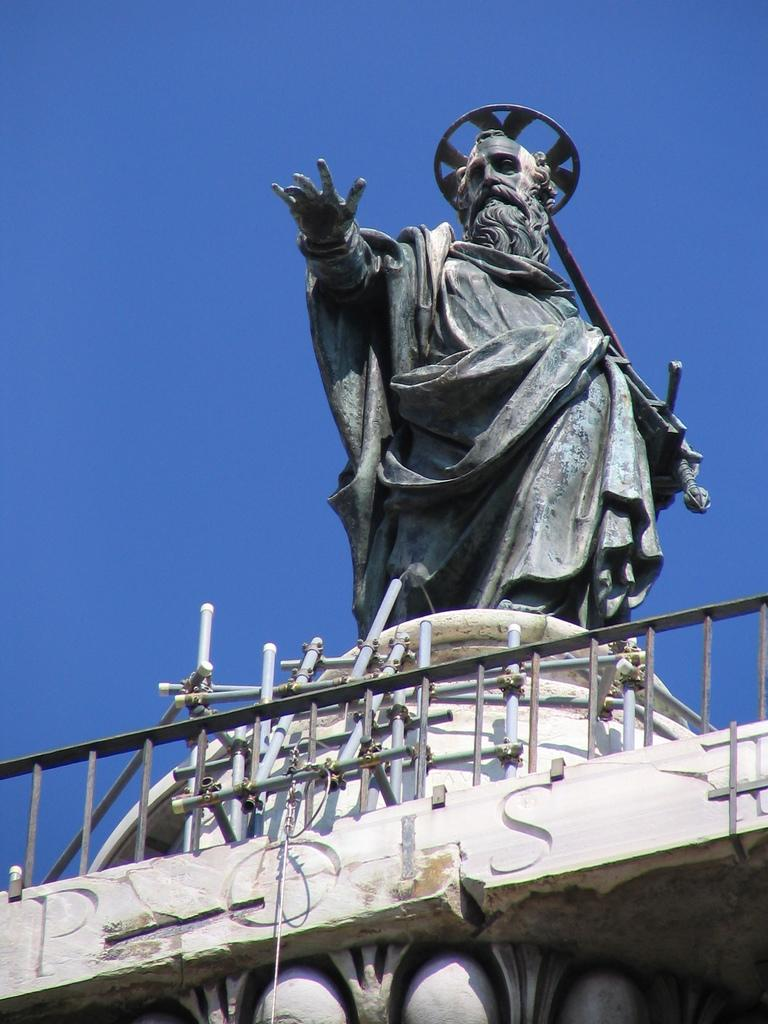What is the main subject in the image? There is a statue in the image. What else can be seen in the image besides the statue? There is fencing in the image. What is the color of the sky in the image? The sky is visible in the image and has a blue color. What type of thing is floating in the air in the image? There is no thing floating in the air in the image. What time of day is it in the image, considering the afternoon? The time of day is not specified in the image, and there is no indication of it being the afternoon. 